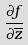<formula> <loc_0><loc_0><loc_500><loc_500>\frac { \partial f } { \partial \overline { z } }</formula> 